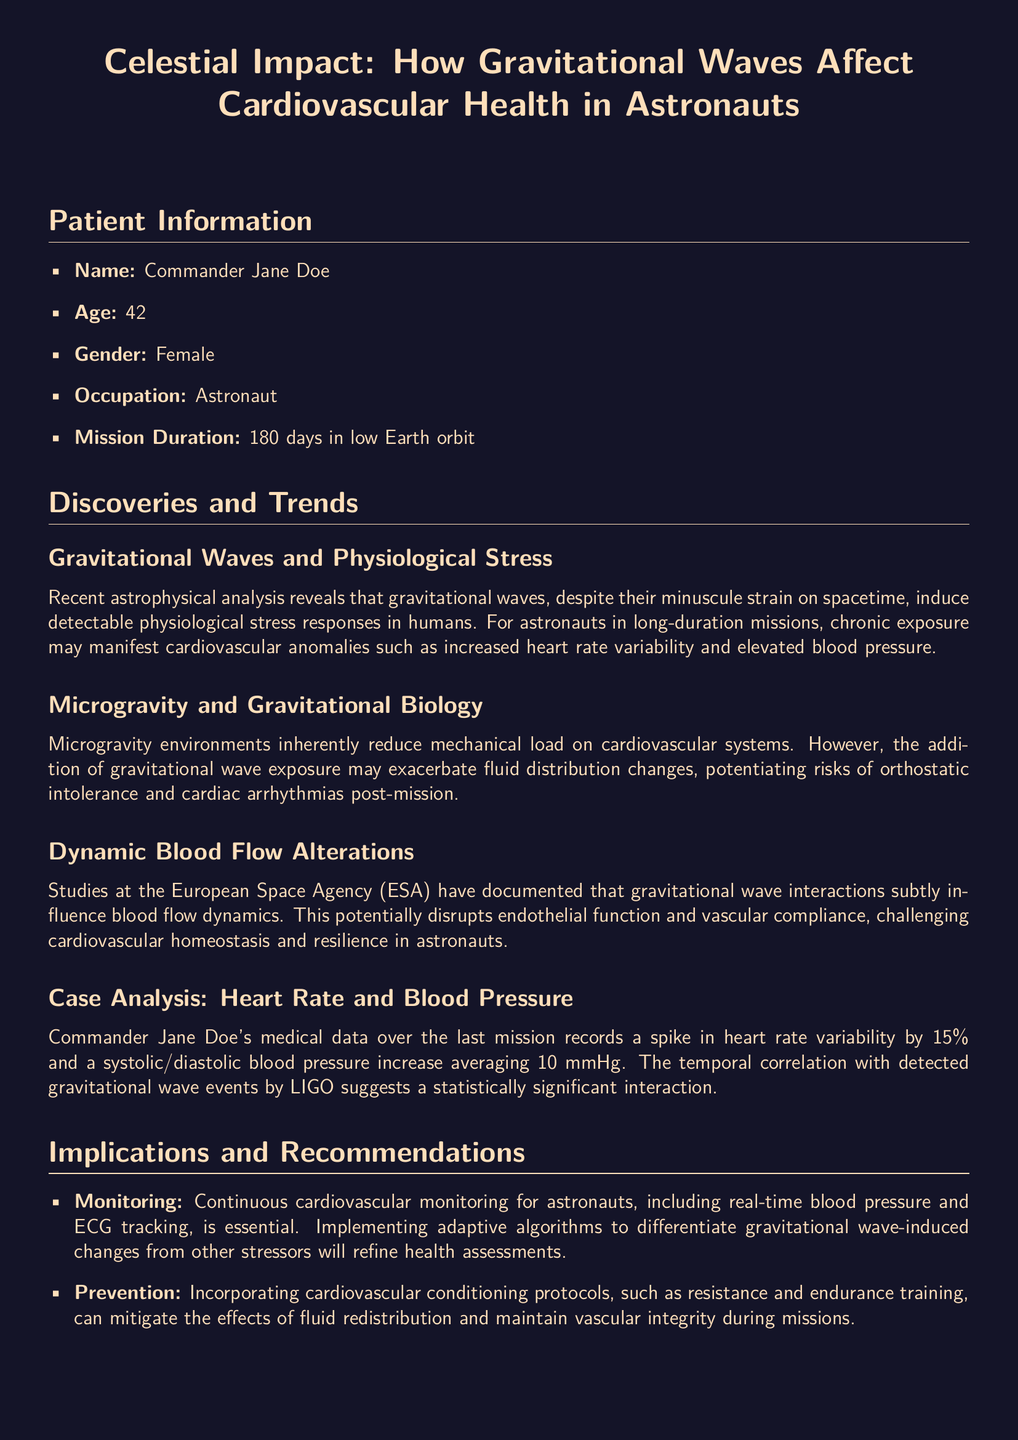What is the name of the astronaut? The document states that the astronaut's name is Commander Jane Doe.
Answer: Commander Jane Doe What is Commander Jane Doe's age? The age of Commander Jane Doe, as mentioned in the document, is 42.
Answer: 42 How long was the mission duration? The document specifies that the mission duration was 180 days in low Earth orbit.
Answer: 180 days What was the increase in heart rate variability? The document notes a spike in heart rate variability by 15%.
Answer: 15% What average increase in blood pressure was recorded? The systolic/diastolic blood pressure increase averaged 10 mmHg, as indicated in the document.
Answer: 10 mmHg What did the studies at the European Space Agency document? The document states that studies documented that gravitational wave interactions influence blood flow dynamics.
Answer: Blood flow dynamics What is a recommendation for post-mission rehabilitation? The document recommends a structured rehabilitation post-mission should focus on gradual re-acclimatization of cardiovascular function.
Answer: Gradual re-acclimatization What is the primary focus of cardiovascular conditioning protocols? The document suggests that cardiovascular conditioning protocols should mitigate the effects of fluid redistribution.
Answer: Mitigate fluid redistribution What significant interaction is suggested in the document? The document suggests a statistically significant interaction with detected gravitational wave events by LIGO.
Answer: Statistically significant interaction 